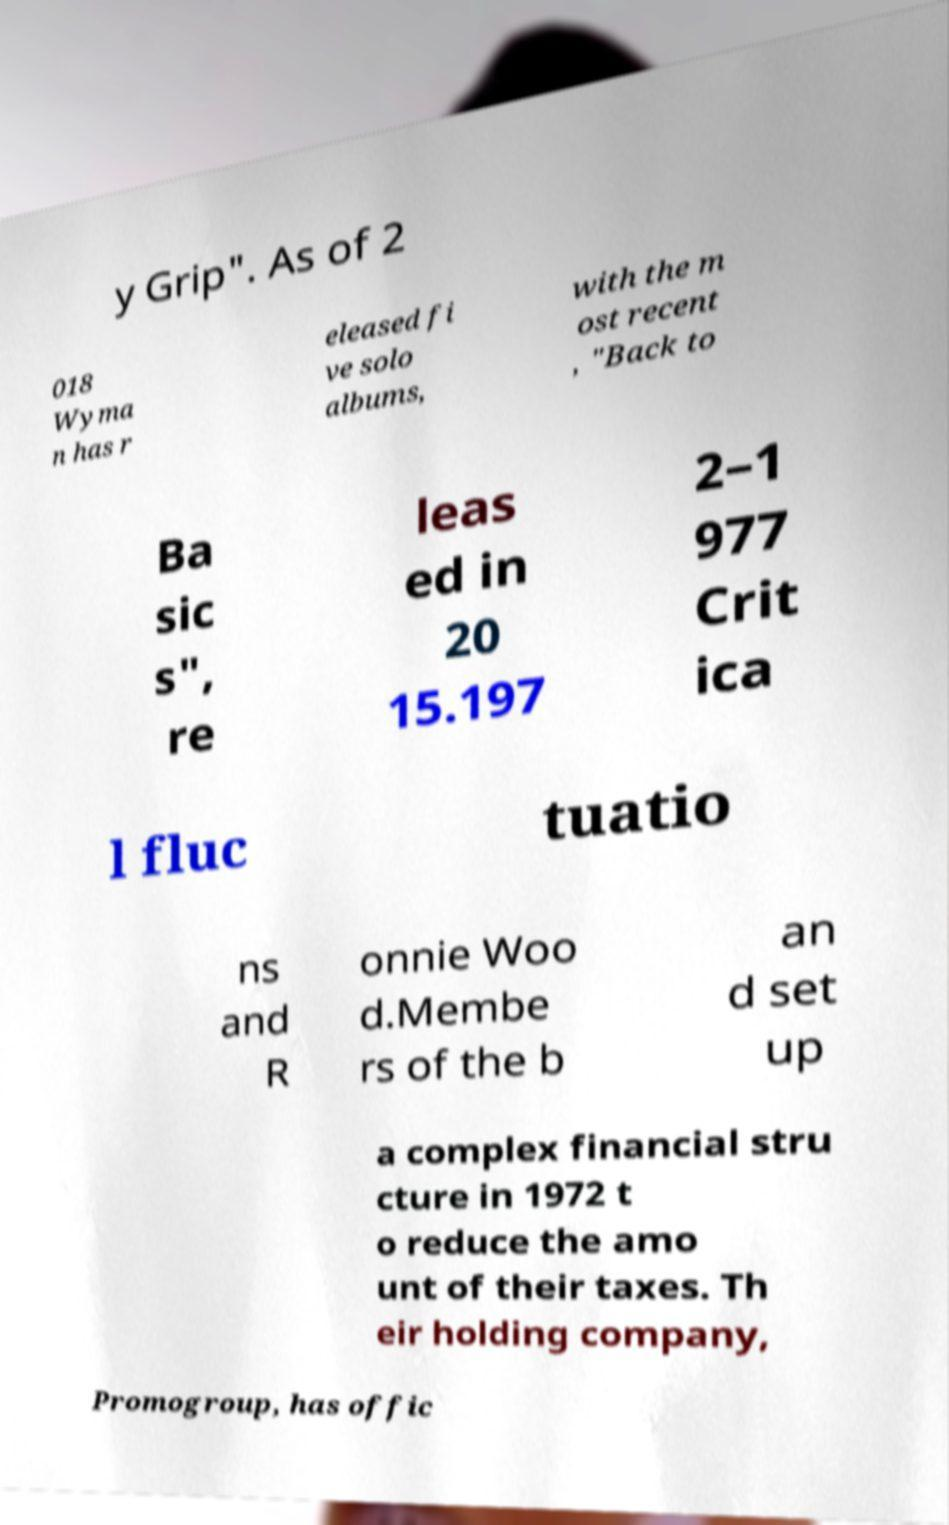Please identify and transcribe the text found in this image. y Grip". As of 2 018 Wyma n has r eleased fi ve solo albums, with the m ost recent , "Back to Ba sic s", re leas ed in 20 15.197 2–1 977 Crit ica l fluc tuatio ns and R onnie Woo d.Membe rs of the b an d set up a complex financial stru cture in 1972 t o reduce the amo unt of their taxes. Th eir holding company, Promogroup, has offic 